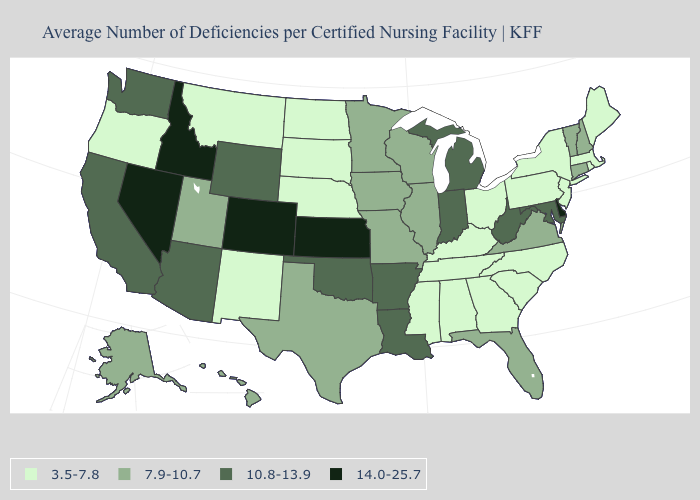Among the states that border Michigan , which have the lowest value?
Concise answer only. Ohio. Name the states that have a value in the range 3.5-7.8?
Be succinct. Alabama, Georgia, Kentucky, Maine, Massachusetts, Mississippi, Montana, Nebraska, New Jersey, New Mexico, New York, North Carolina, North Dakota, Ohio, Oregon, Pennsylvania, Rhode Island, South Carolina, South Dakota, Tennessee. Name the states that have a value in the range 10.8-13.9?
Short answer required. Arizona, Arkansas, California, Indiana, Louisiana, Maryland, Michigan, Oklahoma, Washington, West Virginia, Wyoming. What is the value of Colorado?
Quick response, please. 14.0-25.7. Name the states that have a value in the range 10.8-13.9?
Keep it brief. Arizona, Arkansas, California, Indiana, Louisiana, Maryland, Michigan, Oklahoma, Washington, West Virginia, Wyoming. Name the states that have a value in the range 3.5-7.8?
Short answer required. Alabama, Georgia, Kentucky, Maine, Massachusetts, Mississippi, Montana, Nebraska, New Jersey, New Mexico, New York, North Carolina, North Dakota, Ohio, Oregon, Pennsylvania, Rhode Island, South Carolina, South Dakota, Tennessee. Among the states that border Missouri , which have the lowest value?
Concise answer only. Kentucky, Nebraska, Tennessee. What is the value of Wyoming?
Be succinct. 10.8-13.9. Which states have the lowest value in the Northeast?
Short answer required. Maine, Massachusetts, New Jersey, New York, Pennsylvania, Rhode Island. Among the states that border Arkansas , which have the highest value?
Short answer required. Louisiana, Oklahoma. Is the legend a continuous bar?
Answer briefly. No. Among the states that border Colorado , does Nebraska have the lowest value?
Answer briefly. Yes. Does Kansas have the highest value in the MidWest?
Be succinct. Yes. Does Delaware have the highest value in the South?
Be succinct. Yes. Name the states that have a value in the range 10.8-13.9?
Quick response, please. Arizona, Arkansas, California, Indiana, Louisiana, Maryland, Michigan, Oklahoma, Washington, West Virginia, Wyoming. 